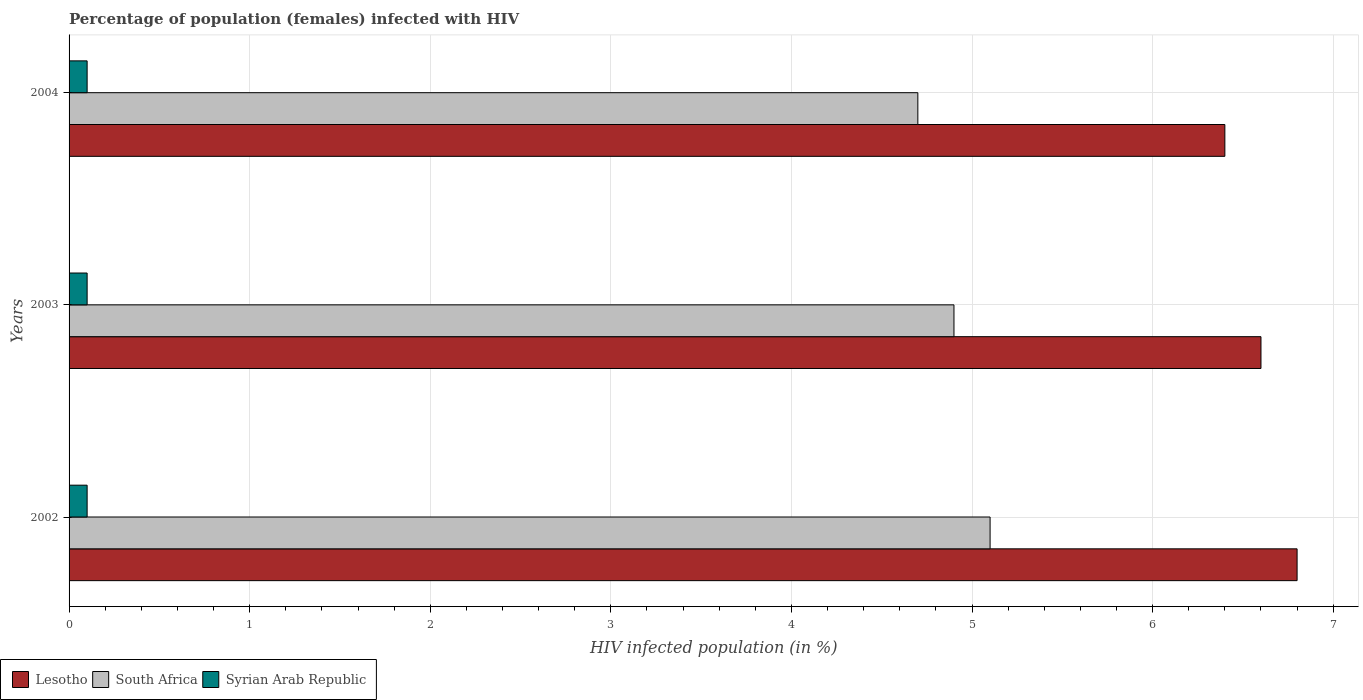Are the number of bars per tick equal to the number of legend labels?
Your answer should be compact. Yes. How many bars are there on the 2nd tick from the top?
Offer a very short reply. 3. How many bars are there on the 1st tick from the bottom?
Provide a short and direct response. 3. What is the label of the 2nd group of bars from the top?
Offer a terse response. 2003. In how many cases, is the number of bars for a given year not equal to the number of legend labels?
Offer a terse response. 0. What is the percentage of HIV infected female population in Syrian Arab Republic in 2003?
Your response must be concise. 0.1. Across all years, what is the maximum percentage of HIV infected female population in Lesotho?
Provide a short and direct response. 6.8. In which year was the percentage of HIV infected female population in Syrian Arab Republic maximum?
Your response must be concise. 2002. In which year was the percentage of HIV infected female population in South Africa minimum?
Provide a succinct answer. 2004. What is the total percentage of HIV infected female population in Syrian Arab Republic in the graph?
Your answer should be compact. 0.3. What is the difference between the percentage of HIV infected female population in Syrian Arab Republic in 2003 and that in 2004?
Your answer should be very brief. 0. What is the difference between the percentage of HIV infected female population in Lesotho in 2004 and the percentage of HIV infected female population in South Africa in 2002?
Your answer should be compact. 1.3. What is the average percentage of HIV infected female population in South Africa per year?
Provide a succinct answer. 4.9. In the year 2002, what is the difference between the percentage of HIV infected female population in South Africa and percentage of HIV infected female population in Syrian Arab Republic?
Ensure brevity in your answer.  5. What is the ratio of the percentage of HIV infected female population in Syrian Arab Republic in 2002 to that in 2003?
Give a very brief answer. 1. What is the difference between the highest and the second highest percentage of HIV infected female population in South Africa?
Provide a succinct answer. 0.2. What is the difference between the highest and the lowest percentage of HIV infected female population in Syrian Arab Republic?
Give a very brief answer. 0. In how many years, is the percentage of HIV infected female population in South Africa greater than the average percentage of HIV infected female population in South Africa taken over all years?
Your response must be concise. 2. Is the sum of the percentage of HIV infected female population in Lesotho in 2002 and 2003 greater than the maximum percentage of HIV infected female population in Syrian Arab Republic across all years?
Give a very brief answer. Yes. What does the 2nd bar from the top in 2002 represents?
Provide a succinct answer. South Africa. What does the 2nd bar from the bottom in 2003 represents?
Provide a short and direct response. South Africa. How many bars are there?
Offer a very short reply. 9. Are all the bars in the graph horizontal?
Offer a terse response. Yes. How many years are there in the graph?
Keep it short and to the point. 3. What is the difference between two consecutive major ticks on the X-axis?
Provide a succinct answer. 1. Are the values on the major ticks of X-axis written in scientific E-notation?
Your answer should be very brief. No. Does the graph contain grids?
Offer a terse response. Yes. What is the title of the graph?
Provide a succinct answer. Percentage of population (females) infected with HIV. What is the label or title of the X-axis?
Your answer should be compact. HIV infected population (in %). What is the HIV infected population (in %) in Lesotho in 2002?
Your answer should be very brief. 6.8. What is the HIV infected population (in %) of Syrian Arab Republic in 2002?
Ensure brevity in your answer.  0.1. What is the HIV infected population (in %) of Lesotho in 2003?
Make the answer very short. 6.6. What is the HIV infected population (in %) of Syrian Arab Republic in 2003?
Ensure brevity in your answer.  0.1. What is the HIV infected population (in %) in Lesotho in 2004?
Keep it short and to the point. 6.4. What is the HIV infected population (in %) in South Africa in 2004?
Provide a short and direct response. 4.7. What is the HIV infected population (in %) in Syrian Arab Republic in 2004?
Make the answer very short. 0.1. Across all years, what is the maximum HIV infected population (in %) in South Africa?
Make the answer very short. 5.1. Across all years, what is the maximum HIV infected population (in %) in Syrian Arab Republic?
Your answer should be compact. 0.1. Across all years, what is the minimum HIV infected population (in %) in Lesotho?
Provide a short and direct response. 6.4. Across all years, what is the minimum HIV infected population (in %) of South Africa?
Offer a very short reply. 4.7. Across all years, what is the minimum HIV infected population (in %) of Syrian Arab Republic?
Provide a short and direct response. 0.1. What is the total HIV infected population (in %) of Lesotho in the graph?
Provide a short and direct response. 19.8. What is the total HIV infected population (in %) in South Africa in the graph?
Offer a terse response. 14.7. What is the total HIV infected population (in %) of Syrian Arab Republic in the graph?
Your answer should be very brief. 0.3. What is the difference between the HIV infected population (in %) of Lesotho in 2002 and that in 2003?
Keep it short and to the point. 0.2. What is the difference between the HIV infected population (in %) of South Africa in 2002 and that in 2003?
Your answer should be compact. 0.2. What is the difference between the HIV infected population (in %) of Syrian Arab Republic in 2002 and that in 2003?
Offer a terse response. 0. What is the difference between the HIV infected population (in %) of South Africa in 2002 and that in 2004?
Give a very brief answer. 0.4. What is the difference between the HIV infected population (in %) in Syrian Arab Republic in 2002 and that in 2004?
Your answer should be compact. 0. What is the difference between the HIV infected population (in %) of South Africa in 2003 and that in 2004?
Provide a short and direct response. 0.2. What is the difference between the HIV infected population (in %) of Lesotho in 2002 and the HIV infected population (in %) of Syrian Arab Republic in 2003?
Provide a short and direct response. 6.7. What is the difference between the HIV infected population (in %) in Lesotho in 2002 and the HIV infected population (in %) in South Africa in 2004?
Give a very brief answer. 2.1. What is the difference between the HIV infected population (in %) of Lesotho in 2003 and the HIV infected population (in %) of Syrian Arab Republic in 2004?
Ensure brevity in your answer.  6.5. What is the difference between the HIV infected population (in %) of South Africa in 2003 and the HIV infected population (in %) of Syrian Arab Republic in 2004?
Ensure brevity in your answer.  4.8. What is the average HIV infected population (in %) of Lesotho per year?
Provide a short and direct response. 6.6. In the year 2002, what is the difference between the HIV infected population (in %) of Lesotho and HIV infected population (in %) of South Africa?
Keep it short and to the point. 1.7. In the year 2002, what is the difference between the HIV infected population (in %) of South Africa and HIV infected population (in %) of Syrian Arab Republic?
Keep it short and to the point. 5. In the year 2003, what is the difference between the HIV infected population (in %) in Lesotho and HIV infected population (in %) in South Africa?
Your response must be concise. 1.7. In the year 2003, what is the difference between the HIV infected population (in %) of South Africa and HIV infected population (in %) of Syrian Arab Republic?
Offer a very short reply. 4.8. In the year 2004, what is the difference between the HIV infected population (in %) of Lesotho and HIV infected population (in %) of South Africa?
Offer a very short reply. 1.7. What is the ratio of the HIV infected population (in %) in Lesotho in 2002 to that in 2003?
Provide a short and direct response. 1.03. What is the ratio of the HIV infected population (in %) in South Africa in 2002 to that in 2003?
Offer a very short reply. 1.04. What is the ratio of the HIV infected population (in %) of Lesotho in 2002 to that in 2004?
Ensure brevity in your answer.  1.06. What is the ratio of the HIV infected population (in %) of South Africa in 2002 to that in 2004?
Your answer should be compact. 1.09. What is the ratio of the HIV infected population (in %) in Syrian Arab Republic in 2002 to that in 2004?
Offer a terse response. 1. What is the ratio of the HIV infected population (in %) in Lesotho in 2003 to that in 2004?
Ensure brevity in your answer.  1.03. What is the ratio of the HIV infected population (in %) in South Africa in 2003 to that in 2004?
Your answer should be very brief. 1.04. What is the difference between the highest and the second highest HIV infected population (in %) of Lesotho?
Ensure brevity in your answer.  0.2. What is the difference between the highest and the second highest HIV infected population (in %) in South Africa?
Make the answer very short. 0.2. What is the difference between the highest and the lowest HIV infected population (in %) in Lesotho?
Your response must be concise. 0.4. What is the difference between the highest and the lowest HIV infected population (in %) of South Africa?
Provide a short and direct response. 0.4. 